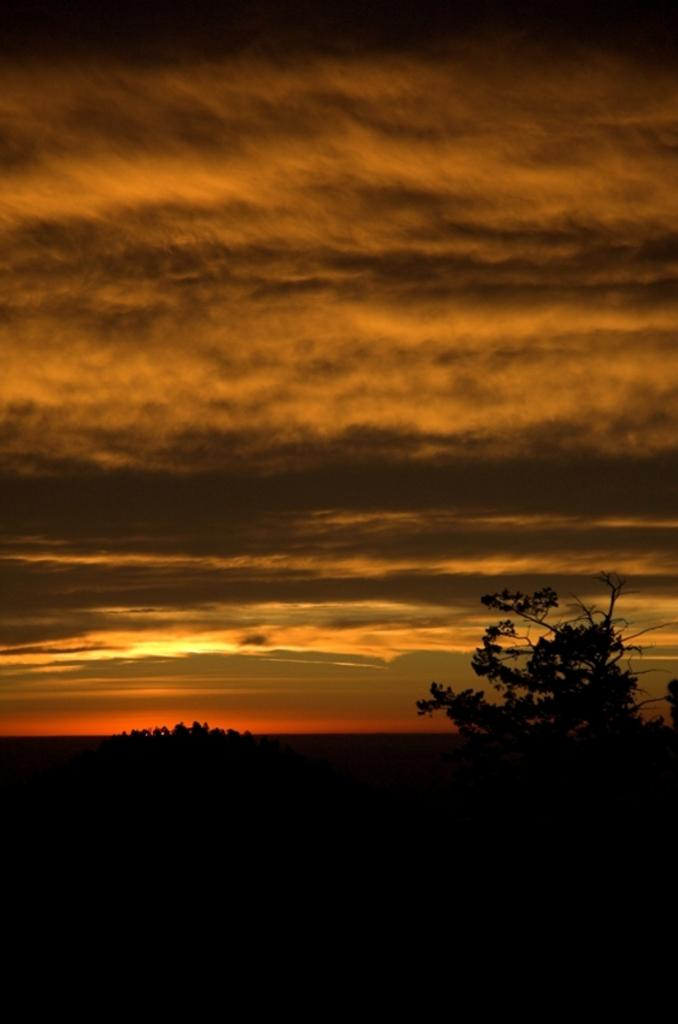What type of vegetation can be seen in the image? There are trees in the image. What part of the natural environment is visible in the image? The sky is visible in the image. What can be observed in the sky? Clouds are present in the sky. How would you describe the overall lighting in the image? The image appears to be dark. What type of verse is being recited by the potato in the image? There is no potato present in the image, and therefore no verse is being recited. Can you describe the battle scene taking place in the image? There is no battle scene present in the image; it features trees, sky, and clouds. 